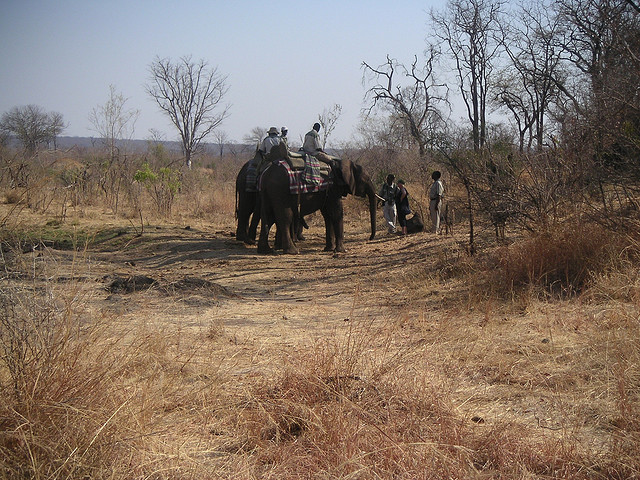<image>What color are the leaves of the tree? I am unable to determine the color of the leaves of the tree. It can be brown, green, or the tree may have no leaves at all. What color are the leaves of the tree? I don't know what color the leaves of the tree are. It seems like they can be brown or green. 